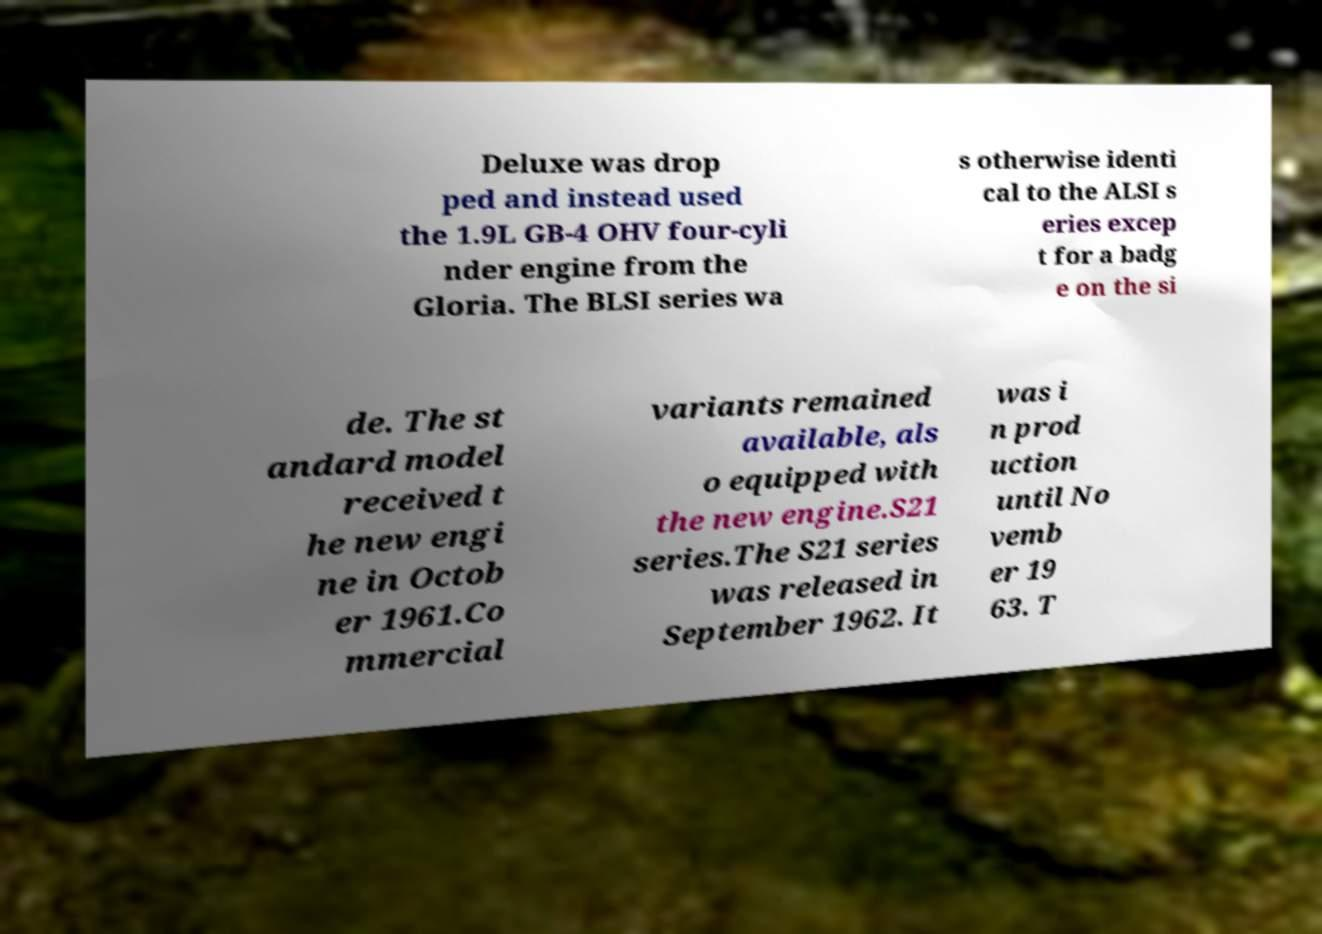For documentation purposes, I need the text within this image transcribed. Could you provide that? Deluxe was drop ped and instead used the 1.9L GB-4 OHV four-cyli nder engine from the Gloria. The BLSI series wa s otherwise identi cal to the ALSI s eries excep t for a badg e on the si de. The st andard model received t he new engi ne in Octob er 1961.Co mmercial variants remained available, als o equipped with the new engine.S21 series.The S21 series was released in September 1962. It was i n prod uction until No vemb er 19 63. T 